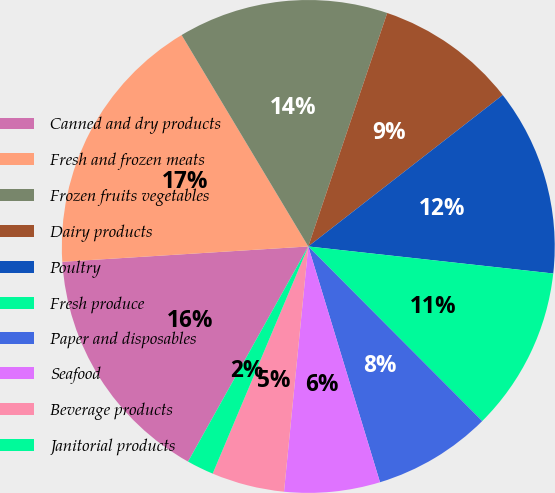Convert chart. <chart><loc_0><loc_0><loc_500><loc_500><pie_chart><fcel>Canned and dry products<fcel>Fresh and frozen meats<fcel>Frozen fruits vegetables<fcel>Dairy products<fcel>Poultry<fcel>Fresh produce<fcel>Paper and disposables<fcel>Seafood<fcel>Beverage products<fcel>Janitorial products<nl><fcel>15.9%<fcel>17.4%<fcel>13.78%<fcel>9.28%<fcel>12.28%<fcel>10.78%<fcel>7.77%<fcel>6.27%<fcel>4.77%<fcel>1.77%<nl></chart> 